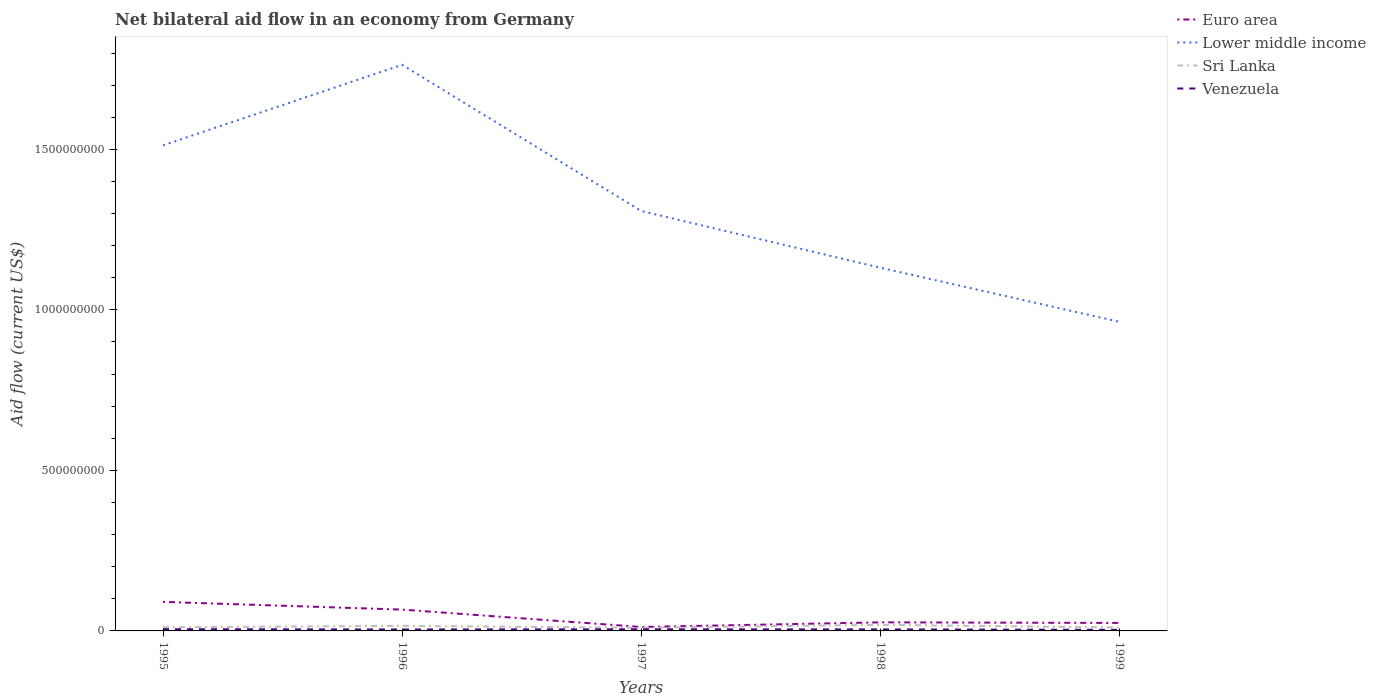How many different coloured lines are there?
Offer a terse response. 4. Does the line corresponding to Euro area intersect with the line corresponding to Lower middle income?
Your response must be concise. No. Is the number of lines equal to the number of legend labels?
Provide a short and direct response. Yes. Across all years, what is the maximum net bilateral aid flow in Sri Lanka?
Offer a very short reply. 9.75e+06. In which year was the net bilateral aid flow in Lower middle income maximum?
Your answer should be compact. 1999. What is the total net bilateral aid flow in Lower middle income in the graph?
Give a very brief answer. 5.50e+08. What is the difference between the highest and the second highest net bilateral aid flow in Sri Lanka?
Make the answer very short. 9.24e+06. How many lines are there?
Provide a succinct answer. 4. Does the graph contain grids?
Provide a short and direct response. No. What is the title of the graph?
Offer a terse response. Net bilateral aid flow in an economy from Germany. What is the label or title of the X-axis?
Provide a short and direct response. Years. What is the Aid flow (current US$) of Euro area in 1995?
Your answer should be very brief. 9.05e+07. What is the Aid flow (current US$) of Lower middle income in 1995?
Your answer should be very brief. 1.51e+09. What is the Aid flow (current US$) in Sri Lanka in 1995?
Your answer should be compact. 1.14e+07. What is the Aid flow (current US$) of Venezuela in 1995?
Provide a short and direct response. 5.30e+06. What is the Aid flow (current US$) of Euro area in 1996?
Your answer should be compact. 6.64e+07. What is the Aid flow (current US$) in Lower middle income in 1996?
Ensure brevity in your answer.  1.76e+09. What is the Aid flow (current US$) of Sri Lanka in 1996?
Ensure brevity in your answer.  1.58e+07. What is the Aid flow (current US$) in Venezuela in 1996?
Ensure brevity in your answer.  4.47e+06. What is the Aid flow (current US$) in Euro area in 1997?
Offer a very short reply. 1.22e+07. What is the Aid flow (current US$) in Lower middle income in 1997?
Your response must be concise. 1.31e+09. What is the Aid flow (current US$) in Sri Lanka in 1997?
Provide a succinct answer. 9.75e+06. What is the Aid flow (current US$) in Euro area in 1998?
Provide a short and direct response. 2.67e+07. What is the Aid flow (current US$) in Lower middle income in 1998?
Give a very brief answer. 1.13e+09. What is the Aid flow (current US$) in Sri Lanka in 1998?
Make the answer very short. 1.90e+07. What is the Aid flow (current US$) in Venezuela in 1998?
Provide a short and direct response. 4.66e+06. What is the Aid flow (current US$) of Euro area in 1999?
Keep it short and to the point. 2.49e+07. What is the Aid flow (current US$) in Lower middle income in 1999?
Ensure brevity in your answer.  9.63e+08. What is the Aid flow (current US$) of Sri Lanka in 1999?
Ensure brevity in your answer.  1.08e+07. What is the Aid flow (current US$) of Venezuela in 1999?
Keep it short and to the point. 3.36e+06. Across all years, what is the maximum Aid flow (current US$) of Euro area?
Offer a terse response. 9.05e+07. Across all years, what is the maximum Aid flow (current US$) of Lower middle income?
Keep it short and to the point. 1.76e+09. Across all years, what is the maximum Aid flow (current US$) of Sri Lanka?
Your response must be concise. 1.90e+07. Across all years, what is the maximum Aid flow (current US$) of Venezuela?
Ensure brevity in your answer.  5.30e+06. Across all years, what is the minimum Aid flow (current US$) in Euro area?
Your answer should be compact. 1.22e+07. Across all years, what is the minimum Aid flow (current US$) in Lower middle income?
Provide a succinct answer. 9.63e+08. Across all years, what is the minimum Aid flow (current US$) of Sri Lanka?
Make the answer very short. 9.75e+06. Across all years, what is the minimum Aid flow (current US$) of Venezuela?
Keep it short and to the point. 3.36e+06. What is the total Aid flow (current US$) in Euro area in the graph?
Provide a succinct answer. 2.21e+08. What is the total Aid flow (current US$) in Lower middle income in the graph?
Provide a succinct answer. 6.68e+09. What is the total Aid flow (current US$) of Sri Lanka in the graph?
Give a very brief answer. 6.68e+07. What is the total Aid flow (current US$) of Venezuela in the graph?
Provide a succinct answer. 2.28e+07. What is the difference between the Aid flow (current US$) in Euro area in 1995 and that in 1996?
Your response must be concise. 2.41e+07. What is the difference between the Aid flow (current US$) of Lower middle income in 1995 and that in 1996?
Offer a very short reply. -2.51e+08. What is the difference between the Aid flow (current US$) in Sri Lanka in 1995 and that in 1996?
Ensure brevity in your answer.  -4.44e+06. What is the difference between the Aid flow (current US$) in Venezuela in 1995 and that in 1996?
Provide a short and direct response. 8.30e+05. What is the difference between the Aid flow (current US$) of Euro area in 1995 and that in 1997?
Your answer should be very brief. 7.82e+07. What is the difference between the Aid flow (current US$) of Lower middle income in 1995 and that in 1997?
Keep it short and to the point. 2.05e+08. What is the difference between the Aid flow (current US$) of Sri Lanka in 1995 and that in 1997?
Your answer should be compact. 1.65e+06. What is the difference between the Aid flow (current US$) in Venezuela in 1995 and that in 1997?
Ensure brevity in your answer.  3.00e+05. What is the difference between the Aid flow (current US$) of Euro area in 1995 and that in 1998?
Offer a very short reply. 6.38e+07. What is the difference between the Aid flow (current US$) of Lower middle income in 1995 and that in 1998?
Provide a succinct answer. 3.81e+08. What is the difference between the Aid flow (current US$) of Sri Lanka in 1995 and that in 1998?
Your answer should be very brief. -7.59e+06. What is the difference between the Aid flow (current US$) in Venezuela in 1995 and that in 1998?
Provide a short and direct response. 6.40e+05. What is the difference between the Aid flow (current US$) of Euro area in 1995 and that in 1999?
Make the answer very short. 6.56e+07. What is the difference between the Aid flow (current US$) of Lower middle income in 1995 and that in 1999?
Your answer should be compact. 5.50e+08. What is the difference between the Aid flow (current US$) of Sri Lanka in 1995 and that in 1999?
Offer a very short reply. 6.20e+05. What is the difference between the Aid flow (current US$) of Venezuela in 1995 and that in 1999?
Make the answer very short. 1.94e+06. What is the difference between the Aid flow (current US$) of Euro area in 1996 and that in 1997?
Provide a succinct answer. 5.42e+07. What is the difference between the Aid flow (current US$) of Lower middle income in 1996 and that in 1997?
Your response must be concise. 4.55e+08. What is the difference between the Aid flow (current US$) of Sri Lanka in 1996 and that in 1997?
Provide a short and direct response. 6.09e+06. What is the difference between the Aid flow (current US$) in Venezuela in 1996 and that in 1997?
Make the answer very short. -5.30e+05. What is the difference between the Aid flow (current US$) in Euro area in 1996 and that in 1998?
Keep it short and to the point. 3.97e+07. What is the difference between the Aid flow (current US$) of Lower middle income in 1996 and that in 1998?
Give a very brief answer. 6.32e+08. What is the difference between the Aid flow (current US$) in Sri Lanka in 1996 and that in 1998?
Keep it short and to the point. -3.15e+06. What is the difference between the Aid flow (current US$) of Euro area in 1996 and that in 1999?
Your response must be concise. 4.15e+07. What is the difference between the Aid flow (current US$) of Lower middle income in 1996 and that in 1999?
Give a very brief answer. 8.01e+08. What is the difference between the Aid flow (current US$) of Sri Lanka in 1996 and that in 1999?
Provide a succinct answer. 5.06e+06. What is the difference between the Aid flow (current US$) in Venezuela in 1996 and that in 1999?
Make the answer very short. 1.11e+06. What is the difference between the Aid flow (current US$) in Euro area in 1997 and that in 1998?
Ensure brevity in your answer.  -1.45e+07. What is the difference between the Aid flow (current US$) of Lower middle income in 1997 and that in 1998?
Your response must be concise. 1.77e+08. What is the difference between the Aid flow (current US$) in Sri Lanka in 1997 and that in 1998?
Your response must be concise. -9.24e+06. What is the difference between the Aid flow (current US$) of Venezuela in 1997 and that in 1998?
Provide a short and direct response. 3.40e+05. What is the difference between the Aid flow (current US$) in Euro area in 1997 and that in 1999?
Your answer should be compact. -1.27e+07. What is the difference between the Aid flow (current US$) of Lower middle income in 1997 and that in 1999?
Offer a very short reply. 3.45e+08. What is the difference between the Aid flow (current US$) in Sri Lanka in 1997 and that in 1999?
Ensure brevity in your answer.  -1.03e+06. What is the difference between the Aid flow (current US$) in Venezuela in 1997 and that in 1999?
Give a very brief answer. 1.64e+06. What is the difference between the Aid flow (current US$) in Euro area in 1998 and that in 1999?
Offer a terse response. 1.81e+06. What is the difference between the Aid flow (current US$) in Lower middle income in 1998 and that in 1999?
Ensure brevity in your answer.  1.69e+08. What is the difference between the Aid flow (current US$) of Sri Lanka in 1998 and that in 1999?
Offer a very short reply. 8.21e+06. What is the difference between the Aid flow (current US$) of Venezuela in 1998 and that in 1999?
Offer a very short reply. 1.30e+06. What is the difference between the Aid flow (current US$) of Euro area in 1995 and the Aid flow (current US$) of Lower middle income in 1996?
Your response must be concise. -1.67e+09. What is the difference between the Aid flow (current US$) in Euro area in 1995 and the Aid flow (current US$) in Sri Lanka in 1996?
Give a very brief answer. 7.46e+07. What is the difference between the Aid flow (current US$) in Euro area in 1995 and the Aid flow (current US$) in Venezuela in 1996?
Provide a short and direct response. 8.60e+07. What is the difference between the Aid flow (current US$) in Lower middle income in 1995 and the Aid flow (current US$) in Sri Lanka in 1996?
Provide a succinct answer. 1.50e+09. What is the difference between the Aid flow (current US$) of Lower middle income in 1995 and the Aid flow (current US$) of Venezuela in 1996?
Your response must be concise. 1.51e+09. What is the difference between the Aid flow (current US$) of Sri Lanka in 1995 and the Aid flow (current US$) of Venezuela in 1996?
Provide a short and direct response. 6.93e+06. What is the difference between the Aid flow (current US$) of Euro area in 1995 and the Aid flow (current US$) of Lower middle income in 1997?
Give a very brief answer. -1.22e+09. What is the difference between the Aid flow (current US$) in Euro area in 1995 and the Aid flow (current US$) in Sri Lanka in 1997?
Make the answer very short. 8.07e+07. What is the difference between the Aid flow (current US$) of Euro area in 1995 and the Aid flow (current US$) of Venezuela in 1997?
Keep it short and to the point. 8.55e+07. What is the difference between the Aid flow (current US$) in Lower middle income in 1995 and the Aid flow (current US$) in Sri Lanka in 1997?
Your response must be concise. 1.50e+09. What is the difference between the Aid flow (current US$) in Lower middle income in 1995 and the Aid flow (current US$) in Venezuela in 1997?
Provide a short and direct response. 1.51e+09. What is the difference between the Aid flow (current US$) in Sri Lanka in 1995 and the Aid flow (current US$) in Venezuela in 1997?
Your response must be concise. 6.40e+06. What is the difference between the Aid flow (current US$) in Euro area in 1995 and the Aid flow (current US$) in Lower middle income in 1998?
Ensure brevity in your answer.  -1.04e+09. What is the difference between the Aid flow (current US$) of Euro area in 1995 and the Aid flow (current US$) of Sri Lanka in 1998?
Provide a short and direct response. 7.15e+07. What is the difference between the Aid flow (current US$) in Euro area in 1995 and the Aid flow (current US$) in Venezuela in 1998?
Give a very brief answer. 8.58e+07. What is the difference between the Aid flow (current US$) of Lower middle income in 1995 and the Aid flow (current US$) of Sri Lanka in 1998?
Your answer should be very brief. 1.49e+09. What is the difference between the Aid flow (current US$) in Lower middle income in 1995 and the Aid flow (current US$) in Venezuela in 1998?
Keep it short and to the point. 1.51e+09. What is the difference between the Aid flow (current US$) of Sri Lanka in 1995 and the Aid flow (current US$) of Venezuela in 1998?
Give a very brief answer. 6.74e+06. What is the difference between the Aid flow (current US$) in Euro area in 1995 and the Aid flow (current US$) in Lower middle income in 1999?
Give a very brief answer. -8.72e+08. What is the difference between the Aid flow (current US$) in Euro area in 1995 and the Aid flow (current US$) in Sri Lanka in 1999?
Keep it short and to the point. 7.97e+07. What is the difference between the Aid flow (current US$) in Euro area in 1995 and the Aid flow (current US$) in Venezuela in 1999?
Keep it short and to the point. 8.71e+07. What is the difference between the Aid flow (current US$) in Lower middle income in 1995 and the Aid flow (current US$) in Sri Lanka in 1999?
Make the answer very short. 1.50e+09. What is the difference between the Aid flow (current US$) in Lower middle income in 1995 and the Aid flow (current US$) in Venezuela in 1999?
Make the answer very short. 1.51e+09. What is the difference between the Aid flow (current US$) of Sri Lanka in 1995 and the Aid flow (current US$) of Venezuela in 1999?
Provide a short and direct response. 8.04e+06. What is the difference between the Aid flow (current US$) in Euro area in 1996 and the Aid flow (current US$) in Lower middle income in 1997?
Make the answer very short. -1.24e+09. What is the difference between the Aid flow (current US$) in Euro area in 1996 and the Aid flow (current US$) in Sri Lanka in 1997?
Offer a very short reply. 5.67e+07. What is the difference between the Aid flow (current US$) in Euro area in 1996 and the Aid flow (current US$) in Venezuela in 1997?
Offer a terse response. 6.14e+07. What is the difference between the Aid flow (current US$) of Lower middle income in 1996 and the Aid flow (current US$) of Sri Lanka in 1997?
Your response must be concise. 1.75e+09. What is the difference between the Aid flow (current US$) in Lower middle income in 1996 and the Aid flow (current US$) in Venezuela in 1997?
Your response must be concise. 1.76e+09. What is the difference between the Aid flow (current US$) in Sri Lanka in 1996 and the Aid flow (current US$) in Venezuela in 1997?
Offer a very short reply. 1.08e+07. What is the difference between the Aid flow (current US$) of Euro area in 1996 and the Aid flow (current US$) of Lower middle income in 1998?
Your answer should be compact. -1.06e+09. What is the difference between the Aid flow (current US$) in Euro area in 1996 and the Aid flow (current US$) in Sri Lanka in 1998?
Provide a succinct answer. 4.74e+07. What is the difference between the Aid flow (current US$) in Euro area in 1996 and the Aid flow (current US$) in Venezuela in 1998?
Your answer should be compact. 6.18e+07. What is the difference between the Aid flow (current US$) of Lower middle income in 1996 and the Aid flow (current US$) of Sri Lanka in 1998?
Give a very brief answer. 1.74e+09. What is the difference between the Aid flow (current US$) in Lower middle income in 1996 and the Aid flow (current US$) in Venezuela in 1998?
Offer a very short reply. 1.76e+09. What is the difference between the Aid flow (current US$) of Sri Lanka in 1996 and the Aid flow (current US$) of Venezuela in 1998?
Ensure brevity in your answer.  1.12e+07. What is the difference between the Aid flow (current US$) of Euro area in 1996 and the Aid flow (current US$) of Lower middle income in 1999?
Offer a very short reply. -8.96e+08. What is the difference between the Aid flow (current US$) in Euro area in 1996 and the Aid flow (current US$) in Sri Lanka in 1999?
Offer a very short reply. 5.56e+07. What is the difference between the Aid flow (current US$) of Euro area in 1996 and the Aid flow (current US$) of Venezuela in 1999?
Ensure brevity in your answer.  6.30e+07. What is the difference between the Aid flow (current US$) of Lower middle income in 1996 and the Aid flow (current US$) of Sri Lanka in 1999?
Offer a very short reply. 1.75e+09. What is the difference between the Aid flow (current US$) in Lower middle income in 1996 and the Aid flow (current US$) in Venezuela in 1999?
Give a very brief answer. 1.76e+09. What is the difference between the Aid flow (current US$) of Sri Lanka in 1996 and the Aid flow (current US$) of Venezuela in 1999?
Give a very brief answer. 1.25e+07. What is the difference between the Aid flow (current US$) of Euro area in 1997 and the Aid flow (current US$) of Lower middle income in 1998?
Keep it short and to the point. -1.12e+09. What is the difference between the Aid flow (current US$) in Euro area in 1997 and the Aid flow (current US$) in Sri Lanka in 1998?
Provide a short and direct response. -6.75e+06. What is the difference between the Aid flow (current US$) in Euro area in 1997 and the Aid flow (current US$) in Venezuela in 1998?
Offer a very short reply. 7.58e+06. What is the difference between the Aid flow (current US$) of Lower middle income in 1997 and the Aid flow (current US$) of Sri Lanka in 1998?
Your answer should be very brief. 1.29e+09. What is the difference between the Aid flow (current US$) in Lower middle income in 1997 and the Aid flow (current US$) in Venezuela in 1998?
Give a very brief answer. 1.30e+09. What is the difference between the Aid flow (current US$) of Sri Lanka in 1997 and the Aid flow (current US$) of Venezuela in 1998?
Give a very brief answer. 5.09e+06. What is the difference between the Aid flow (current US$) of Euro area in 1997 and the Aid flow (current US$) of Lower middle income in 1999?
Keep it short and to the point. -9.51e+08. What is the difference between the Aid flow (current US$) in Euro area in 1997 and the Aid flow (current US$) in Sri Lanka in 1999?
Ensure brevity in your answer.  1.46e+06. What is the difference between the Aid flow (current US$) of Euro area in 1997 and the Aid flow (current US$) of Venezuela in 1999?
Give a very brief answer. 8.88e+06. What is the difference between the Aid flow (current US$) in Lower middle income in 1997 and the Aid flow (current US$) in Sri Lanka in 1999?
Provide a short and direct response. 1.30e+09. What is the difference between the Aid flow (current US$) of Lower middle income in 1997 and the Aid flow (current US$) of Venezuela in 1999?
Your answer should be compact. 1.30e+09. What is the difference between the Aid flow (current US$) in Sri Lanka in 1997 and the Aid flow (current US$) in Venezuela in 1999?
Ensure brevity in your answer.  6.39e+06. What is the difference between the Aid flow (current US$) in Euro area in 1998 and the Aid flow (current US$) in Lower middle income in 1999?
Your answer should be very brief. -9.36e+08. What is the difference between the Aid flow (current US$) of Euro area in 1998 and the Aid flow (current US$) of Sri Lanka in 1999?
Provide a short and direct response. 1.59e+07. What is the difference between the Aid flow (current US$) in Euro area in 1998 and the Aid flow (current US$) in Venezuela in 1999?
Provide a succinct answer. 2.34e+07. What is the difference between the Aid flow (current US$) in Lower middle income in 1998 and the Aid flow (current US$) in Sri Lanka in 1999?
Offer a very short reply. 1.12e+09. What is the difference between the Aid flow (current US$) of Lower middle income in 1998 and the Aid flow (current US$) of Venezuela in 1999?
Your response must be concise. 1.13e+09. What is the difference between the Aid flow (current US$) of Sri Lanka in 1998 and the Aid flow (current US$) of Venezuela in 1999?
Provide a short and direct response. 1.56e+07. What is the average Aid flow (current US$) of Euro area per year?
Make the answer very short. 4.41e+07. What is the average Aid flow (current US$) in Lower middle income per year?
Offer a very short reply. 1.34e+09. What is the average Aid flow (current US$) in Sri Lanka per year?
Keep it short and to the point. 1.34e+07. What is the average Aid flow (current US$) of Venezuela per year?
Provide a succinct answer. 4.56e+06. In the year 1995, what is the difference between the Aid flow (current US$) of Euro area and Aid flow (current US$) of Lower middle income?
Your answer should be very brief. -1.42e+09. In the year 1995, what is the difference between the Aid flow (current US$) of Euro area and Aid flow (current US$) of Sri Lanka?
Ensure brevity in your answer.  7.91e+07. In the year 1995, what is the difference between the Aid flow (current US$) in Euro area and Aid flow (current US$) in Venezuela?
Your response must be concise. 8.52e+07. In the year 1995, what is the difference between the Aid flow (current US$) of Lower middle income and Aid flow (current US$) of Sri Lanka?
Ensure brevity in your answer.  1.50e+09. In the year 1995, what is the difference between the Aid flow (current US$) in Lower middle income and Aid flow (current US$) in Venezuela?
Keep it short and to the point. 1.51e+09. In the year 1995, what is the difference between the Aid flow (current US$) of Sri Lanka and Aid flow (current US$) of Venezuela?
Make the answer very short. 6.10e+06. In the year 1996, what is the difference between the Aid flow (current US$) of Euro area and Aid flow (current US$) of Lower middle income?
Ensure brevity in your answer.  -1.70e+09. In the year 1996, what is the difference between the Aid flow (current US$) of Euro area and Aid flow (current US$) of Sri Lanka?
Offer a very short reply. 5.06e+07. In the year 1996, what is the difference between the Aid flow (current US$) of Euro area and Aid flow (current US$) of Venezuela?
Keep it short and to the point. 6.19e+07. In the year 1996, what is the difference between the Aid flow (current US$) of Lower middle income and Aid flow (current US$) of Sri Lanka?
Your response must be concise. 1.75e+09. In the year 1996, what is the difference between the Aid flow (current US$) in Lower middle income and Aid flow (current US$) in Venezuela?
Keep it short and to the point. 1.76e+09. In the year 1996, what is the difference between the Aid flow (current US$) of Sri Lanka and Aid flow (current US$) of Venezuela?
Give a very brief answer. 1.14e+07. In the year 1997, what is the difference between the Aid flow (current US$) of Euro area and Aid flow (current US$) of Lower middle income?
Give a very brief answer. -1.30e+09. In the year 1997, what is the difference between the Aid flow (current US$) in Euro area and Aid flow (current US$) in Sri Lanka?
Keep it short and to the point. 2.49e+06. In the year 1997, what is the difference between the Aid flow (current US$) of Euro area and Aid flow (current US$) of Venezuela?
Provide a short and direct response. 7.24e+06. In the year 1997, what is the difference between the Aid flow (current US$) of Lower middle income and Aid flow (current US$) of Sri Lanka?
Your answer should be very brief. 1.30e+09. In the year 1997, what is the difference between the Aid flow (current US$) in Lower middle income and Aid flow (current US$) in Venezuela?
Your answer should be compact. 1.30e+09. In the year 1997, what is the difference between the Aid flow (current US$) of Sri Lanka and Aid flow (current US$) of Venezuela?
Make the answer very short. 4.75e+06. In the year 1998, what is the difference between the Aid flow (current US$) of Euro area and Aid flow (current US$) of Lower middle income?
Ensure brevity in your answer.  -1.10e+09. In the year 1998, what is the difference between the Aid flow (current US$) of Euro area and Aid flow (current US$) of Sri Lanka?
Your answer should be compact. 7.72e+06. In the year 1998, what is the difference between the Aid flow (current US$) in Euro area and Aid flow (current US$) in Venezuela?
Offer a very short reply. 2.20e+07. In the year 1998, what is the difference between the Aid flow (current US$) in Lower middle income and Aid flow (current US$) in Sri Lanka?
Ensure brevity in your answer.  1.11e+09. In the year 1998, what is the difference between the Aid flow (current US$) of Lower middle income and Aid flow (current US$) of Venezuela?
Provide a short and direct response. 1.13e+09. In the year 1998, what is the difference between the Aid flow (current US$) of Sri Lanka and Aid flow (current US$) of Venezuela?
Offer a terse response. 1.43e+07. In the year 1999, what is the difference between the Aid flow (current US$) of Euro area and Aid flow (current US$) of Lower middle income?
Your answer should be very brief. -9.38e+08. In the year 1999, what is the difference between the Aid flow (current US$) in Euro area and Aid flow (current US$) in Sri Lanka?
Provide a short and direct response. 1.41e+07. In the year 1999, what is the difference between the Aid flow (current US$) of Euro area and Aid flow (current US$) of Venezuela?
Offer a very short reply. 2.15e+07. In the year 1999, what is the difference between the Aid flow (current US$) in Lower middle income and Aid flow (current US$) in Sri Lanka?
Provide a short and direct response. 9.52e+08. In the year 1999, what is the difference between the Aid flow (current US$) in Lower middle income and Aid flow (current US$) in Venezuela?
Provide a succinct answer. 9.59e+08. In the year 1999, what is the difference between the Aid flow (current US$) in Sri Lanka and Aid flow (current US$) in Venezuela?
Your answer should be very brief. 7.42e+06. What is the ratio of the Aid flow (current US$) of Euro area in 1995 to that in 1996?
Your response must be concise. 1.36. What is the ratio of the Aid flow (current US$) in Lower middle income in 1995 to that in 1996?
Provide a short and direct response. 0.86. What is the ratio of the Aid flow (current US$) of Sri Lanka in 1995 to that in 1996?
Provide a succinct answer. 0.72. What is the ratio of the Aid flow (current US$) of Venezuela in 1995 to that in 1996?
Keep it short and to the point. 1.19. What is the ratio of the Aid flow (current US$) in Euro area in 1995 to that in 1997?
Ensure brevity in your answer.  7.39. What is the ratio of the Aid flow (current US$) in Lower middle income in 1995 to that in 1997?
Make the answer very short. 1.16. What is the ratio of the Aid flow (current US$) of Sri Lanka in 1995 to that in 1997?
Keep it short and to the point. 1.17. What is the ratio of the Aid flow (current US$) in Venezuela in 1995 to that in 1997?
Your answer should be very brief. 1.06. What is the ratio of the Aid flow (current US$) of Euro area in 1995 to that in 1998?
Keep it short and to the point. 3.39. What is the ratio of the Aid flow (current US$) of Lower middle income in 1995 to that in 1998?
Give a very brief answer. 1.34. What is the ratio of the Aid flow (current US$) in Sri Lanka in 1995 to that in 1998?
Give a very brief answer. 0.6. What is the ratio of the Aid flow (current US$) in Venezuela in 1995 to that in 1998?
Provide a succinct answer. 1.14. What is the ratio of the Aid flow (current US$) of Euro area in 1995 to that in 1999?
Your answer should be very brief. 3.63. What is the ratio of the Aid flow (current US$) in Lower middle income in 1995 to that in 1999?
Offer a very short reply. 1.57. What is the ratio of the Aid flow (current US$) of Sri Lanka in 1995 to that in 1999?
Your response must be concise. 1.06. What is the ratio of the Aid flow (current US$) in Venezuela in 1995 to that in 1999?
Your response must be concise. 1.58. What is the ratio of the Aid flow (current US$) of Euro area in 1996 to that in 1997?
Ensure brevity in your answer.  5.43. What is the ratio of the Aid flow (current US$) of Lower middle income in 1996 to that in 1997?
Your answer should be compact. 1.35. What is the ratio of the Aid flow (current US$) in Sri Lanka in 1996 to that in 1997?
Provide a succinct answer. 1.62. What is the ratio of the Aid flow (current US$) of Venezuela in 1996 to that in 1997?
Offer a terse response. 0.89. What is the ratio of the Aid flow (current US$) in Euro area in 1996 to that in 1998?
Offer a terse response. 2.49. What is the ratio of the Aid flow (current US$) of Lower middle income in 1996 to that in 1998?
Your answer should be very brief. 1.56. What is the ratio of the Aid flow (current US$) in Sri Lanka in 1996 to that in 1998?
Offer a very short reply. 0.83. What is the ratio of the Aid flow (current US$) in Venezuela in 1996 to that in 1998?
Provide a succinct answer. 0.96. What is the ratio of the Aid flow (current US$) in Euro area in 1996 to that in 1999?
Keep it short and to the point. 2.67. What is the ratio of the Aid flow (current US$) in Lower middle income in 1996 to that in 1999?
Give a very brief answer. 1.83. What is the ratio of the Aid flow (current US$) of Sri Lanka in 1996 to that in 1999?
Provide a short and direct response. 1.47. What is the ratio of the Aid flow (current US$) in Venezuela in 1996 to that in 1999?
Your answer should be compact. 1.33. What is the ratio of the Aid flow (current US$) in Euro area in 1997 to that in 1998?
Give a very brief answer. 0.46. What is the ratio of the Aid flow (current US$) of Lower middle income in 1997 to that in 1998?
Provide a succinct answer. 1.16. What is the ratio of the Aid flow (current US$) in Sri Lanka in 1997 to that in 1998?
Give a very brief answer. 0.51. What is the ratio of the Aid flow (current US$) in Venezuela in 1997 to that in 1998?
Offer a terse response. 1.07. What is the ratio of the Aid flow (current US$) of Euro area in 1997 to that in 1999?
Provide a succinct answer. 0.49. What is the ratio of the Aid flow (current US$) in Lower middle income in 1997 to that in 1999?
Make the answer very short. 1.36. What is the ratio of the Aid flow (current US$) of Sri Lanka in 1997 to that in 1999?
Make the answer very short. 0.9. What is the ratio of the Aid flow (current US$) in Venezuela in 1997 to that in 1999?
Provide a succinct answer. 1.49. What is the ratio of the Aid flow (current US$) in Euro area in 1998 to that in 1999?
Offer a terse response. 1.07. What is the ratio of the Aid flow (current US$) in Lower middle income in 1998 to that in 1999?
Offer a very short reply. 1.18. What is the ratio of the Aid flow (current US$) of Sri Lanka in 1998 to that in 1999?
Make the answer very short. 1.76. What is the ratio of the Aid flow (current US$) in Venezuela in 1998 to that in 1999?
Ensure brevity in your answer.  1.39. What is the difference between the highest and the second highest Aid flow (current US$) of Euro area?
Ensure brevity in your answer.  2.41e+07. What is the difference between the highest and the second highest Aid flow (current US$) in Lower middle income?
Offer a very short reply. 2.51e+08. What is the difference between the highest and the second highest Aid flow (current US$) in Sri Lanka?
Provide a short and direct response. 3.15e+06. What is the difference between the highest and the second highest Aid flow (current US$) of Venezuela?
Provide a short and direct response. 3.00e+05. What is the difference between the highest and the lowest Aid flow (current US$) of Euro area?
Your answer should be compact. 7.82e+07. What is the difference between the highest and the lowest Aid flow (current US$) in Lower middle income?
Offer a very short reply. 8.01e+08. What is the difference between the highest and the lowest Aid flow (current US$) of Sri Lanka?
Your answer should be compact. 9.24e+06. What is the difference between the highest and the lowest Aid flow (current US$) of Venezuela?
Your answer should be very brief. 1.94e+06. 